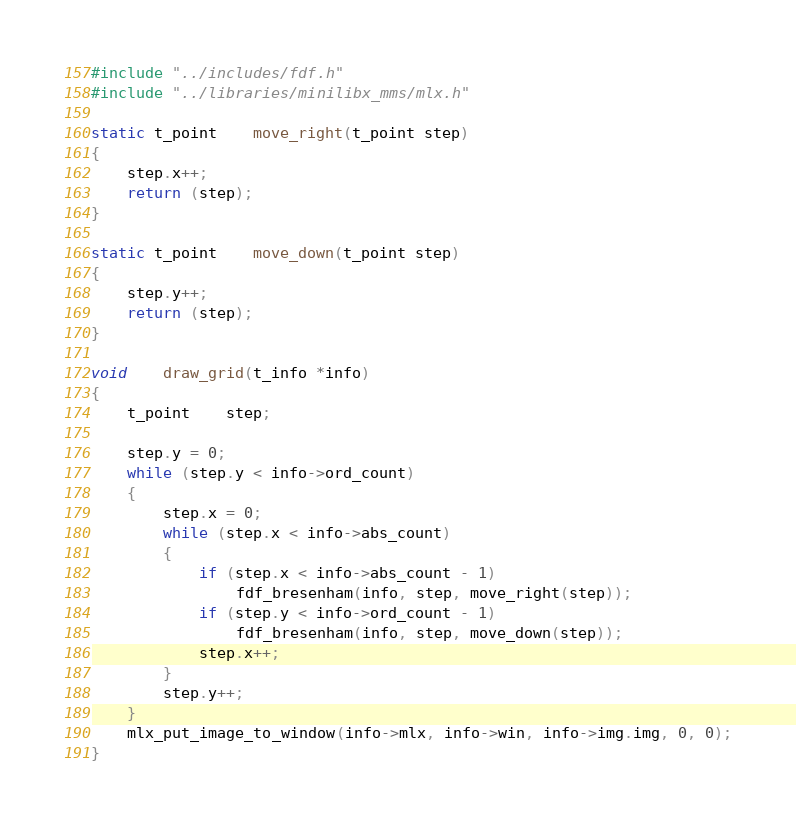<code> <loc_0><loc_0><loc_500><loc_500><_C_>#include "../includes/fdf.h"
#include "../libraries/minilibx_mms/mlx.h"

static t_point	move_right(t_point step)
{
	step.x++;
	return (step);
}

static t_point	move_down(t_point step)
{
	step.y++;
	return (step);
}

void	draw_grid(t_info *info)
{
	t_point	step;

	step.y = 0;
	while (step.y < info->ord_count)
	{
		step.x = 0;
		while (step.x < info->abs_count)
		{
			if (step.x < info->abs_count - 1)
				fdf_bresenham(info, step, move_right(step));
			if (step.y < info->ord_count - 1)
				fdf_bresenham(info, step, move_down(step));
			step.x++;
		}
		step.y++;
	}
	mlx_put_image_to_window(info->mlx, info->win, info->img.img, 0, 0);
}
</code> 